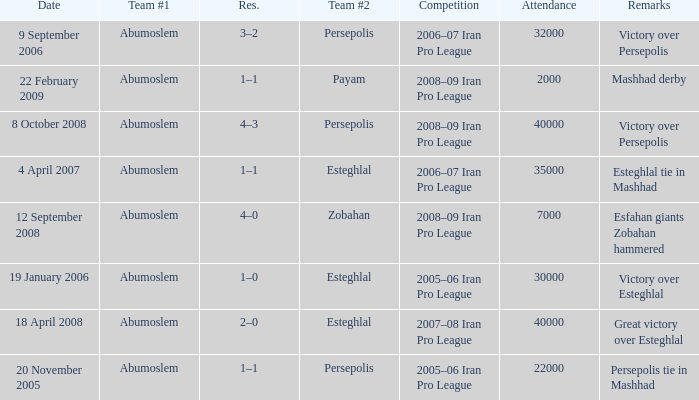Which team held the top position on september 9, 2006? Abumoslem. 